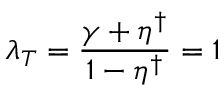<formula> <loc_0><loc_0><loc_500><loc_500>\lambda _ { T } = \frac { \gamma + \eta ^ { \dagger } } { 1 - \eta ^ { \dagger } } = 1</formula> 